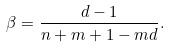Convert formula to latex. <formula><loc_0><loc_0><loc_500><loc_500>\beta = \frac { d - 1 } { n + m + 1 - m d } .</formula> 